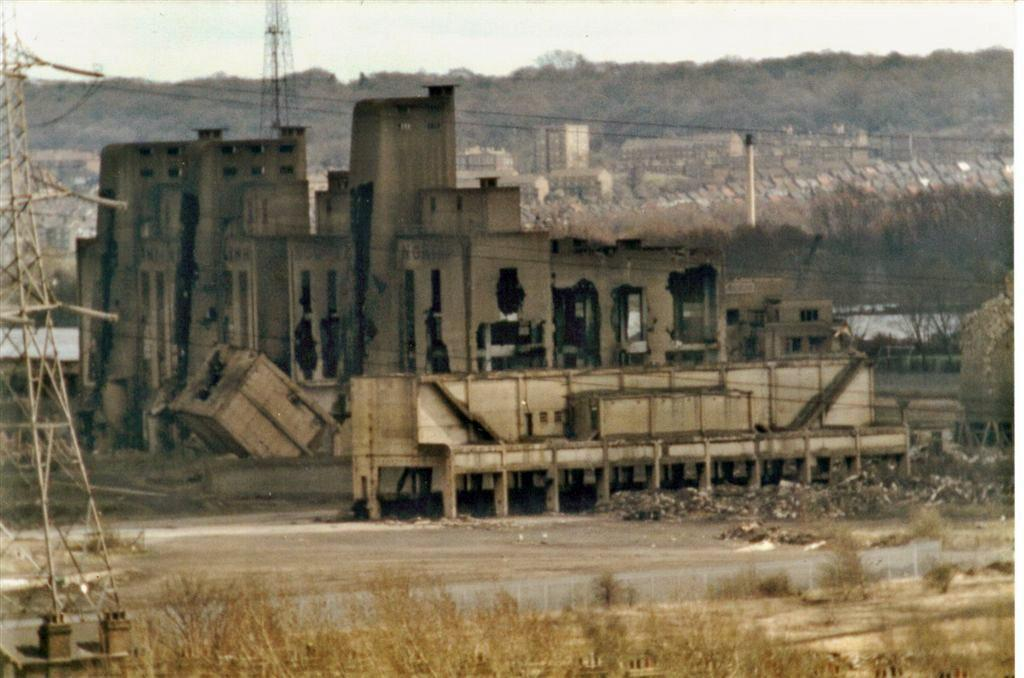What type of structure is in the image? There is an old building in the image. What else can be seen in the image besides the old building? There is an electric pole tower in the image. What is the ground covered with in the image? The ground is covered with dry plants. What type of plantation can be seen in the image? There is no plantation present in the image. What kind of pickle is being served for breakfast in the image? There is no pickle or breakfast depicted in the image. 